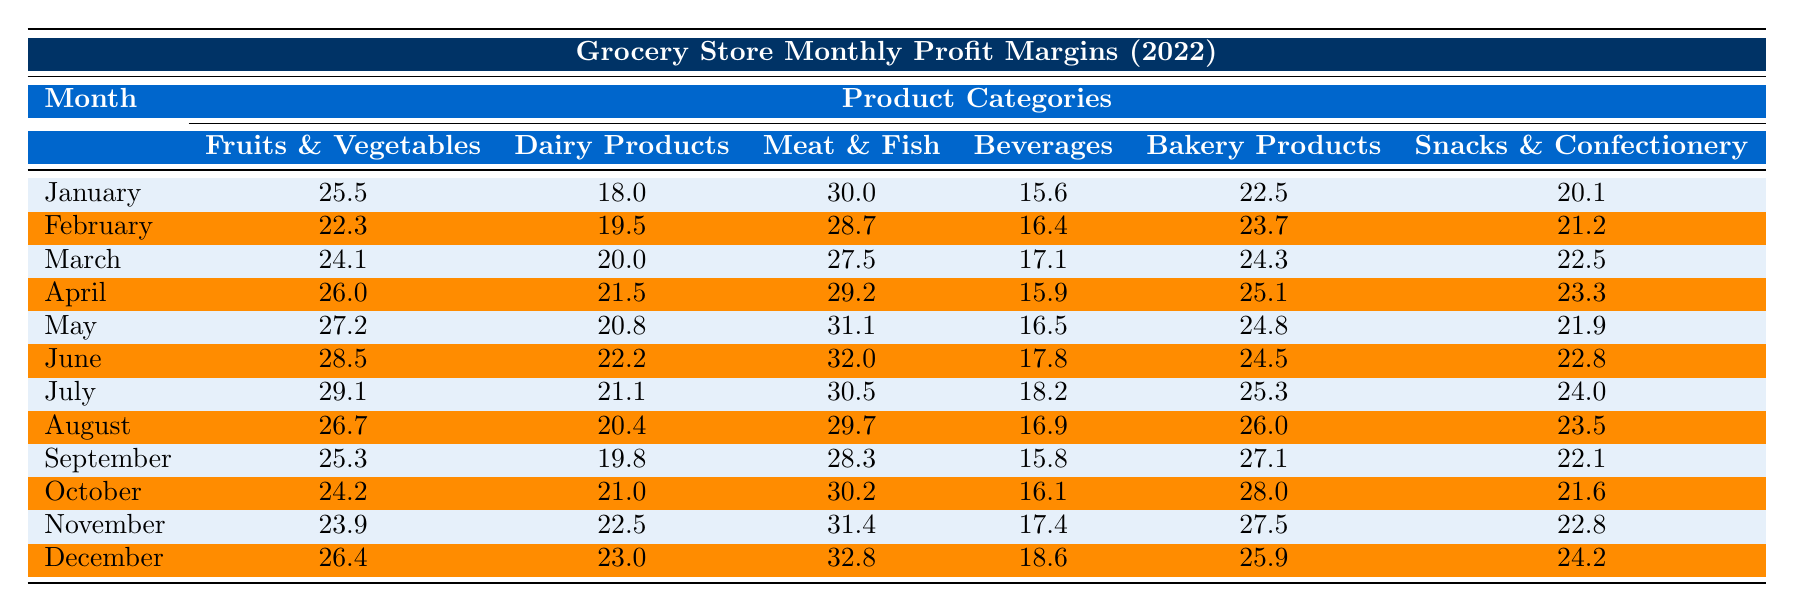What was the profit margin for Dairy Products in June? By looking at the table, we can find the value for Dairy Products in June. It is stated clearly in the row for June under the Dairy Products column.
Answer: 22.2 What month had the highest profit margin for Meat & Fish? We scan through the Meat & Fish column and identify the values. The highest value can be found in December, which is stated clearly.
Answer: 32.8 What is the average profit margin for Beverages over the entire year? We sum the profit margins for Beverages from January to December: (15.6 + 16.4 + 17.1 + 15.9 + 16.5 + 17.8 + 18.2 + 16.9 + 15.8 + 16.1 + 17.4 + 18.6) = 202.9. There are 12 months, so the average is 202.9 / 12 = 16.91.
Answer: 16.9 Which product type had the lowest profit margin in March? We can compare the March values across all product types. By scanning the row for March, we see that Beverages has the lowest profit margin with a value of 17.1.
Answer: 17.1 What month experienced the highest overall profit margin across all categories? First, we need to find the sum of profit margins for each month across all product types. Adding the values together for each month gives the following totals: January (25.5 + 18.0 + 30.0 + 15.6 + 22.5 + 20.1 = 141.7), February (22.3 + 19.5 + 28.7 + 16.4 + 23.7 + 21.2 = 131.8), and so on up to December. The maximum total occurs in June with a sum of 162.6.
Answer: June Is the profit margin for Fruits & Vegetables in October higher than for Dairy Products in November? The profit margin for Fruits & Vegetables in October is 24.2, while that for Dairy Products in November is 22.5. Since 24.2 > 22.5, the statement is true.
Answer: Yes What was the difference in profit margin for Bakery Products between the highest and lowest months? The highest profit margin for Bakery Products is in October (28.0) and the lowest is in January (22.5). To find the difference, we calculate 28.0 - 22.5 = 5.5.
Answer: 5.5 In which month did Snacks & Confectionery achieve the highest profit margin? We need to look at the values listed under Snacks & Confectionery and find the maximum. Scanning the row, we see that July has the highest profit margin with a value of 24.0.
Answer: July What is the trend in profit margins for Fruits & Vegetables from January to July? We observe the profit margins from January (25.5) to July (29.1). Starting from January, the trend is consistently increasing, indicating a positive trend in profit margins through to July.
Answer: Increasing Which product type consistently had the lowest profit margin throughout the year? We check the profit margins month by month for all product types. By scanning each column, it is evident that Beverages had the lowest margins consistently compared to other categories.
Answer: Beverages 